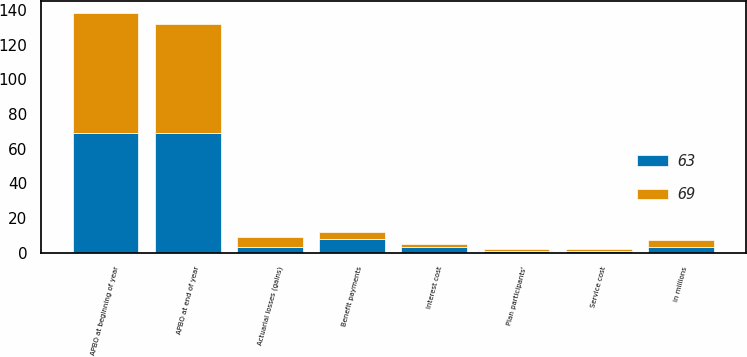Convert chart. <chart><loc_0><loc_0><loc_500><loc_500><stacked_bar_chart><ecel><fcel>in millions<fcel>APBO at beginning of year<fcel>Service cost<fcel>Interest cost<fcel>Plan participants'<fcel>Actuarial losses (gains)<fcel>Benefit payments<fcel>APBO at end of year<nl><fcel>69<fcel>3.5<fcel>69<fcel>1<fcel>2<fcel>1<fcel>6<fcel>4<fcel>63<nl><fcel>63<fcel>3.5<fcel>69<fcel>1<fcel>3<fcel>1<fcel>3<fcel>8<fcel>69<nl></chart> 